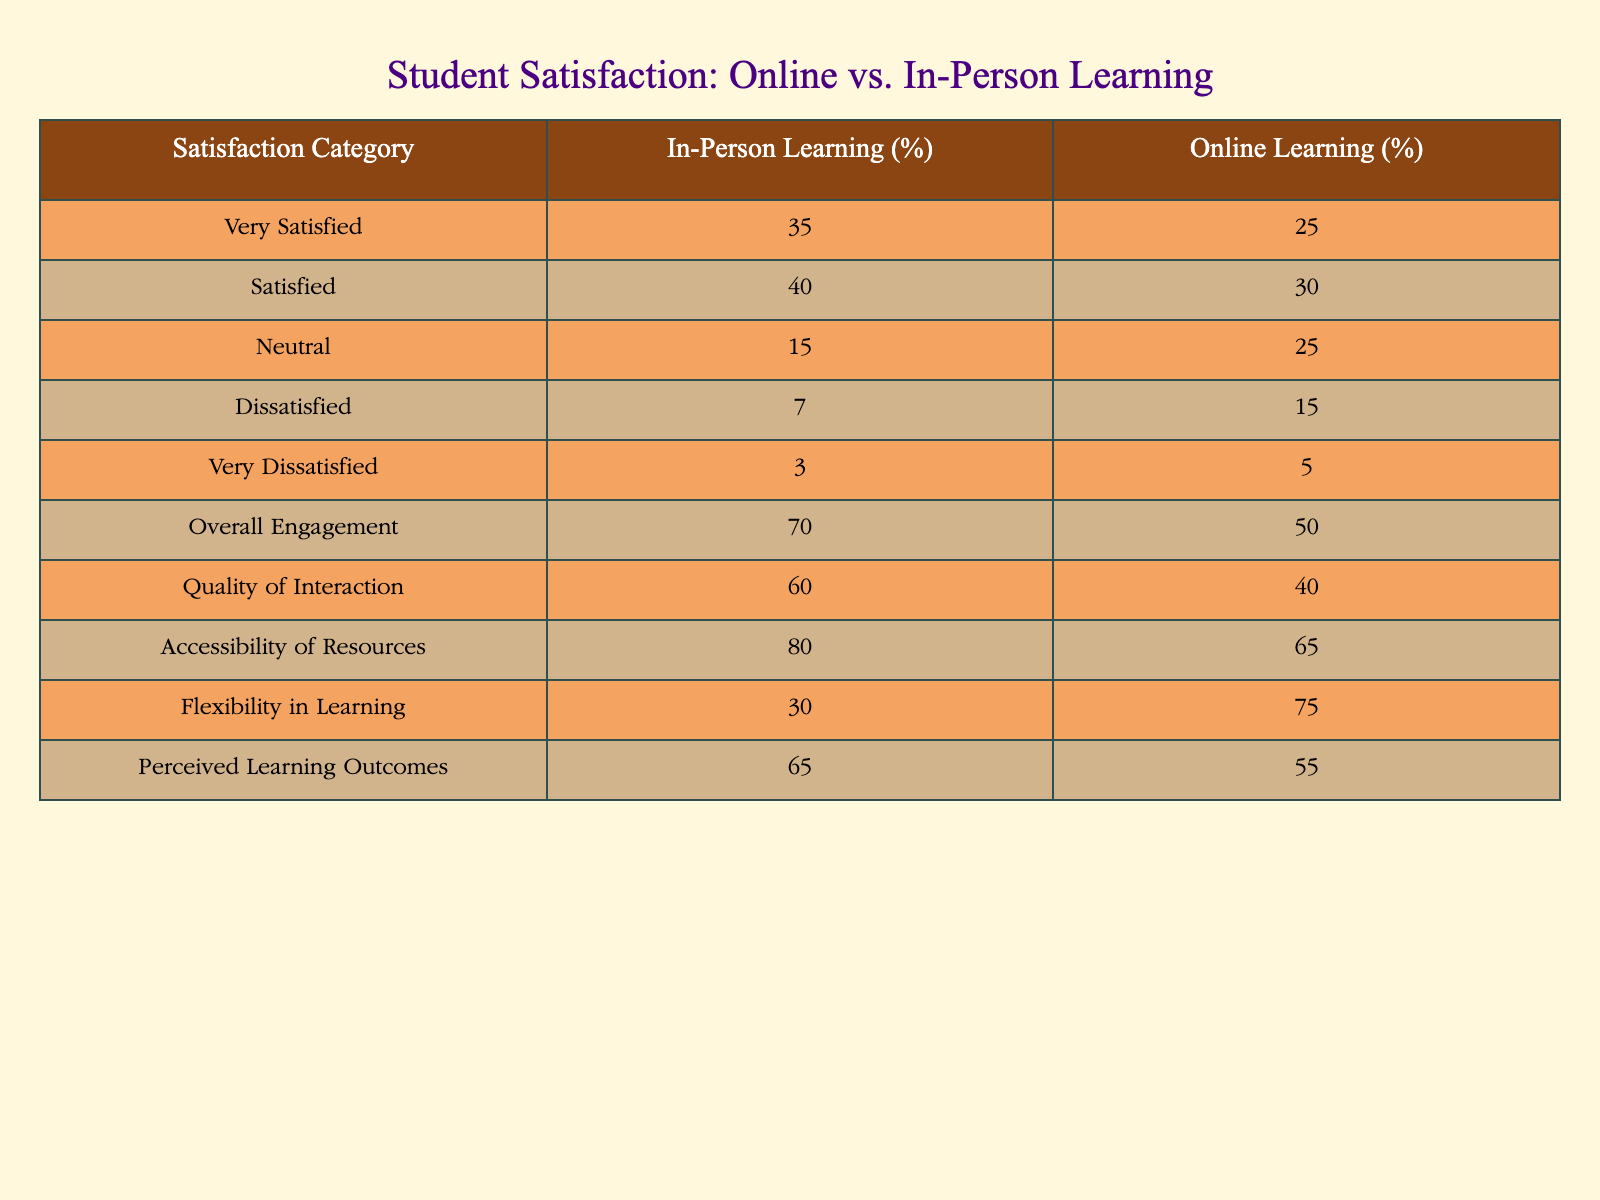What percentage of students reported being very satisfied with in-person learning? According to the table, the percentage of students who reported being very satisfied with in-person learning is directly provided under the "In-Person Learning (%)" column for the "Very Satisfied" satisfaction category. The value is 35%.
Answer: 35% What is the difference in the percentage of students who are satisfied with in-person vs online learning? To find the difference, we look at the "Satisfied" category for both in-person and online learning: In-person is 40% and online is 30%. The difference is calculated by subtracting the online percentage from the in-person percentage: 40% - 30% = 10%.
Answer: 10% Was the overall engagement higher for in-person or online learning? By comparing the "Overall Engagement" percentages in the table, we see that in-person learning has 70% and online learning has 50%. Since 70% is greater than 50%, we conclude that overall engagement was higher for in-person learning.
Answer: Yes What is the percentage of students that were either satisfied or very satisfied with online learning? This requires adding the percentages from the "Satisfied" (30%) and "Very Satisfied" (25%) categories. So, 25% + 30% = 55%.
Answer: 55% If we consider only the “Dissatisfied” category, how does the dissatisfaction rate compare between in-person and online learning? For "Dissatisfied," in-person learning has 7%, while online learning has 15%. By comparing these values, we see that 15% is greater than 7%, indicating that more students are dissatisfied with online learning than with in-person learning.
Answer: No 